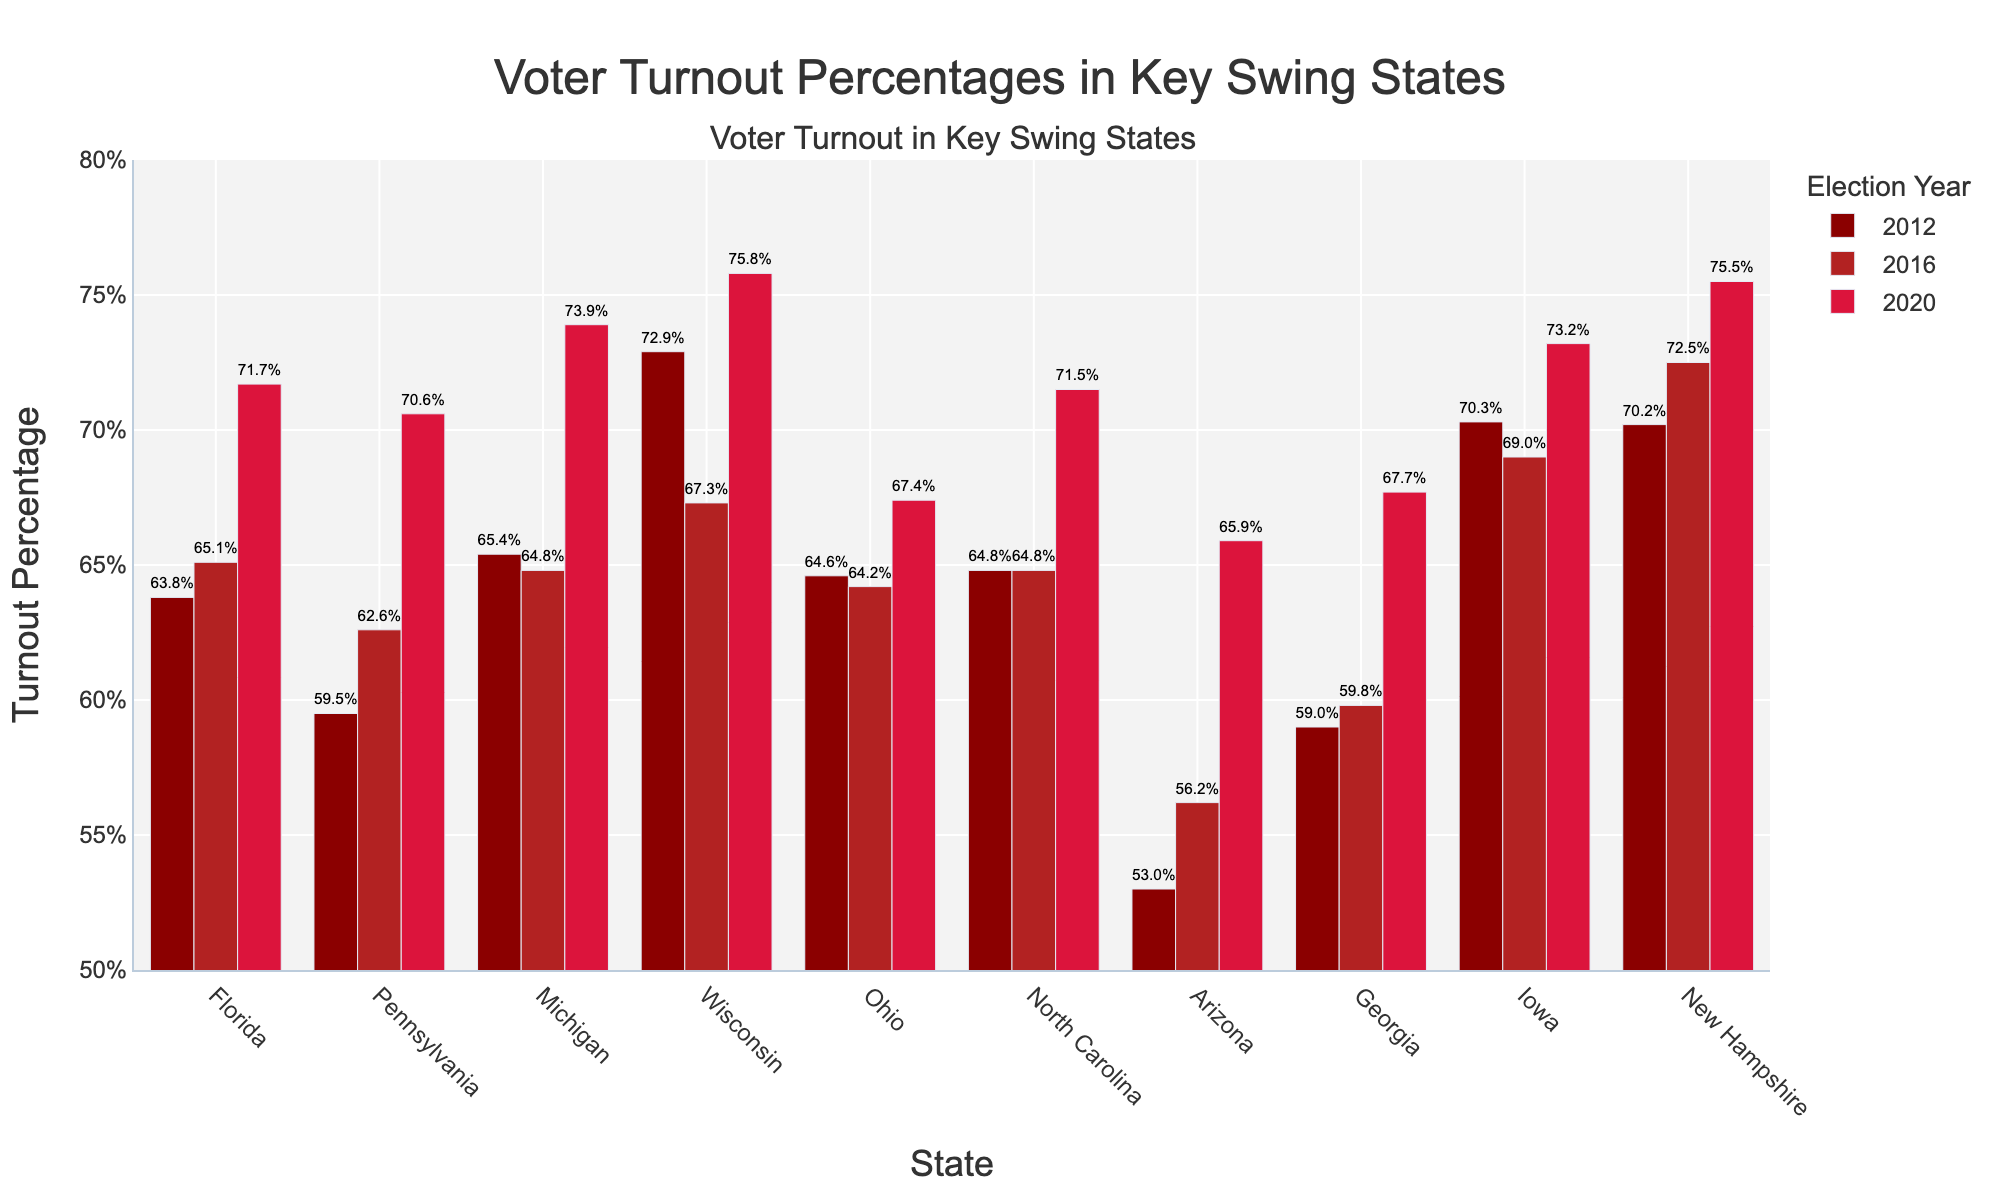What state had the highest voter turnout in 2020? Look at the bars labeled '2020' and identify the highest one. It's the 2020 Wisconsin bar at 75.8%.
Answer: Wisconsin Which state experienced the largest increase in voter turnout from 2012 to 2020? Compare the heights of the bars for 2012 and 2020 for each state. For Wisconsin, the difference is 75.8% - 72.9% = 2.9%, Pennsylvania is 70.6% - 59.5% = 11.1%, etc. The largest difference is Michigan with 73.9% - 65.4% = 8.5%.
Answer: Michigan How did voter turnout in Florida change from 2012 to 2020? Look at the height of the bars for Florida from 2012 to 2020. In 2012, it was 63.8%, and in 2020, it was 71.7%. So, it increased. The change is 71.7% - 63.8% = 7.9%.
Answer: Increased by 7.9% Which states had a turnout greater than 70% in 2020? Identify the bars for 2020 that are taller than the 70% line. These states are New Hampshire, Michigan, Iowa, Wisconsin, Pennsylvania, North Carolina, and Florida.
Answer: New Hampshire, Michigan, Iowa, Wisconsin, Pennsylvania, North Carolina, Florida Among the states, which one had the most consistent voter turnout across the three elections? Compare the differences in the heights of bars for each state across the years. Ohio had close values: 64.6% in 2012, 64.2% in 2016, and 67.4% in 2020, resulting in a minimal difference compared to others.
Answer: Ohio What was the average voter turnout in Arizona over the three elections? Calculate the average of the three percentages for Arizona: (53.0% + 56.2% + 65.9%) / 3 = 58.37%.
Answer: 58.37% Which state had the lowest voter turnout in 2016? Identify the shortest bar for the year 2016. It's the 2016 Arizona bar at 56.2%.
Answer: Arizona Compare the voter turnout trends in Iowa and Georgia from 2012 to 2020. For Iowa, 2012: 70.3%, 2016: 69.0%, 2020: 73.2%; observe that the trend slightly decreased and then increased. For Georgia, 2012: 59.0%, 2016: 59.8%, 2020: 67.7%; observe an increasing trend.
Answer: Iowa fluctuated, Georgia consistently increased 